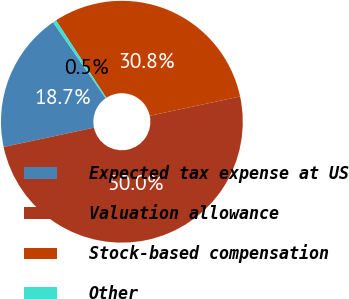<chart> <loc_0><loc_0><loc_500><loc_500><pie_chart><fcel>Expected tax expense at US<fcel>Valuation allowance<fcel>Stock-based compensation<fcel>Other<nl><fcel>18.72%<fcel>50.0%<fcel>30.81%<fcel>0.47%<nl></chart> 